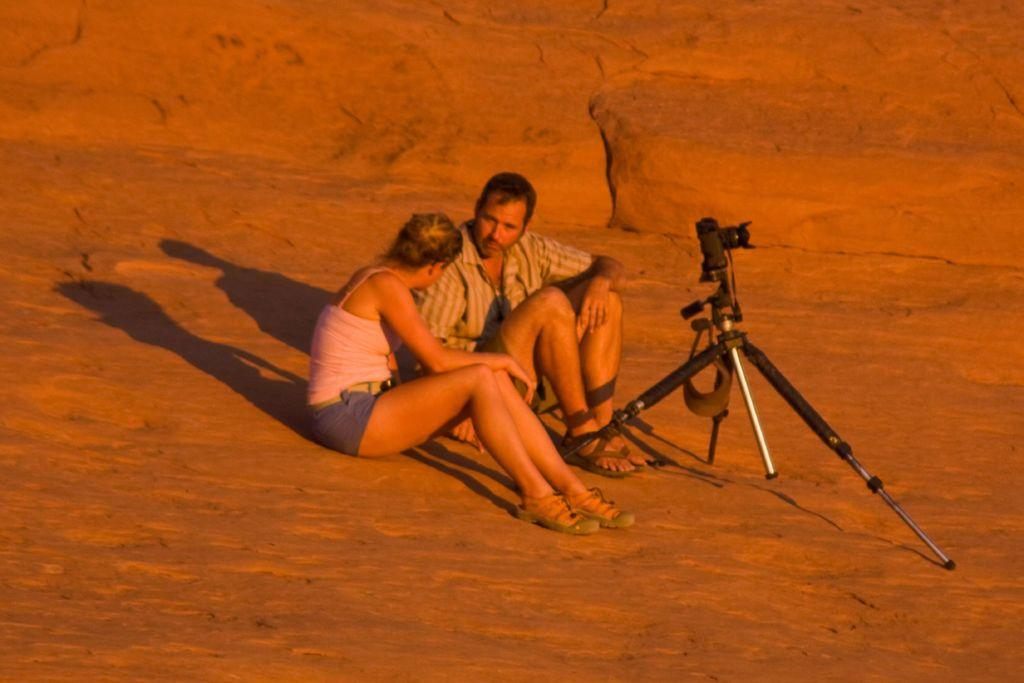How many people are present in the image? There are two people in the image, a man and a woman. What are the man and woman doing in the image? Both the man and woman are sitting on the ground. What objects related to photography can be seen in the image? There is a camera and a camera stand in the image. What type of comb can be seen in the image? There is no comb present in the image. Is the image taken in a place with snow? The provided facts do not mention any snow or snowy environment, so it cannot be determined from the image. 